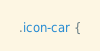Convert code to text. <code><loc_0><loc_0><loc_500><loc_500><_CSS_>.icon-car {</code> 